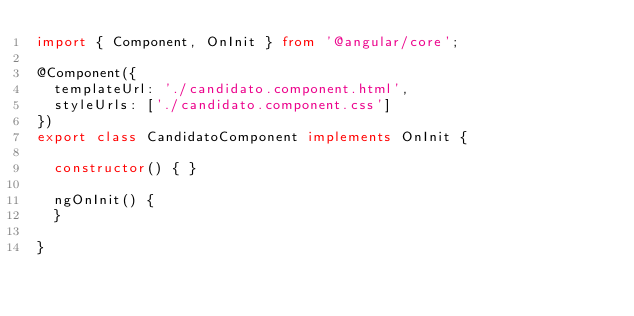<code> <loc_0><loc_0><loc_500><loc_500><_TypeScript_>import { Component, OnInit } from '@angular/core';

@Component({
  templateUrl: './candidato.component.html',
  styleUrls: ['./candidato.component.css']
})
export class CandidatoComponent implements OnInit {

  constructor() { }

  ngOnInit() {
  }

}
</code> 